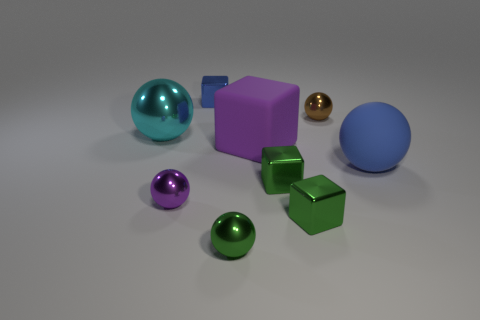How many small green objects are the same shape as the purple metal thing?
Make the answer very short. 1. What material is the purple thing that is the same size as the brown ball?
Your answer should be compact. Metal. Is there a yellow cylinder made of the same material as the large purple block?
Give a very brief answer. No. Is the number of big metallic things on the right side of the purple shiny thing less than the number of large purple cubes?
Offer a very short reply. Yes. What material is the purple object that is in front of the big sphere on the right side of the tiny brown shiny sphere?
Offer a terse response. Metal. There is a tiny object that is both behind the purple shiny thing and on the left side of the rubber block; what shape is it?
Your answer should be very brief. Cube. What number of other things are there of the same color as the matte ball?
Your answer should be compact. 1. How many objects are big balls behind the matte sphere or large red spheres?
Keep it short and to the point. 1. There is a large metal object; is it the same color as the small metal cube behind the cyan shiny thing?
Ensure brevity in your answer.  No. Is there any other thing that has the same size as the blue ball?
Give a very brief answer. Yes. 